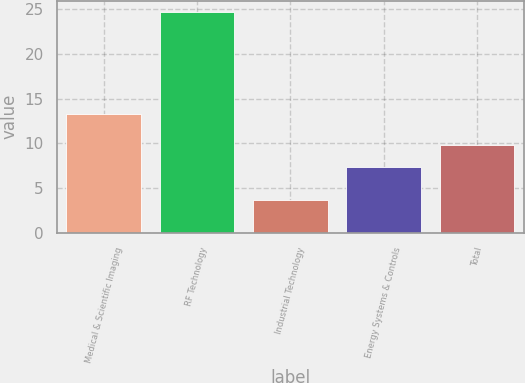<chart> <loc_0><loc_0><loc_500><loc_500><bar_chart><fcel>Medical & Scientific Imaging<fcel>RF Technology<fcel>Industrial Technology<fcel>Energy Systems & Controls<fcel>Total<nl><fcel>13.3<fcel>24.7<fcel>3.7<fcel>7.4<fcel>9.8<nl></chart> 